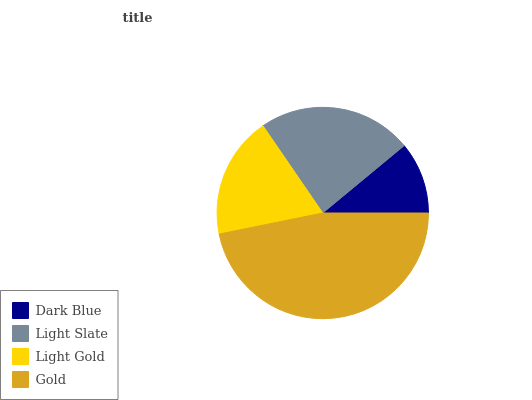Is Dark Blue the minimum?
Answer yes or no. Yes. Is Gold the maximum?
Answer yes or no. Yes. Is Light Slate the minimum?
Answer yes or no. No. Is Light Slate the maximum?
Answer yes or no. No. Is Light Slate greater than Dark Blue?
Answer yes or no. Yes. Is Dark Blue less than Light Slate?
Answer yes or no. Yes. Is Dark Blue greater than Light Slate?
Answer yes or no. No. Is Light Slate less than Dark Blue?
Answer yes or no. No. Is Light Slate the high median?
Answer yes or no. Yes. Is Light Gold the low median?
Answer yes or no. Yes. Is Gold the high median?
Answer yes or no. No. Is Light Slate the low median?
Answer yes or no. No. 